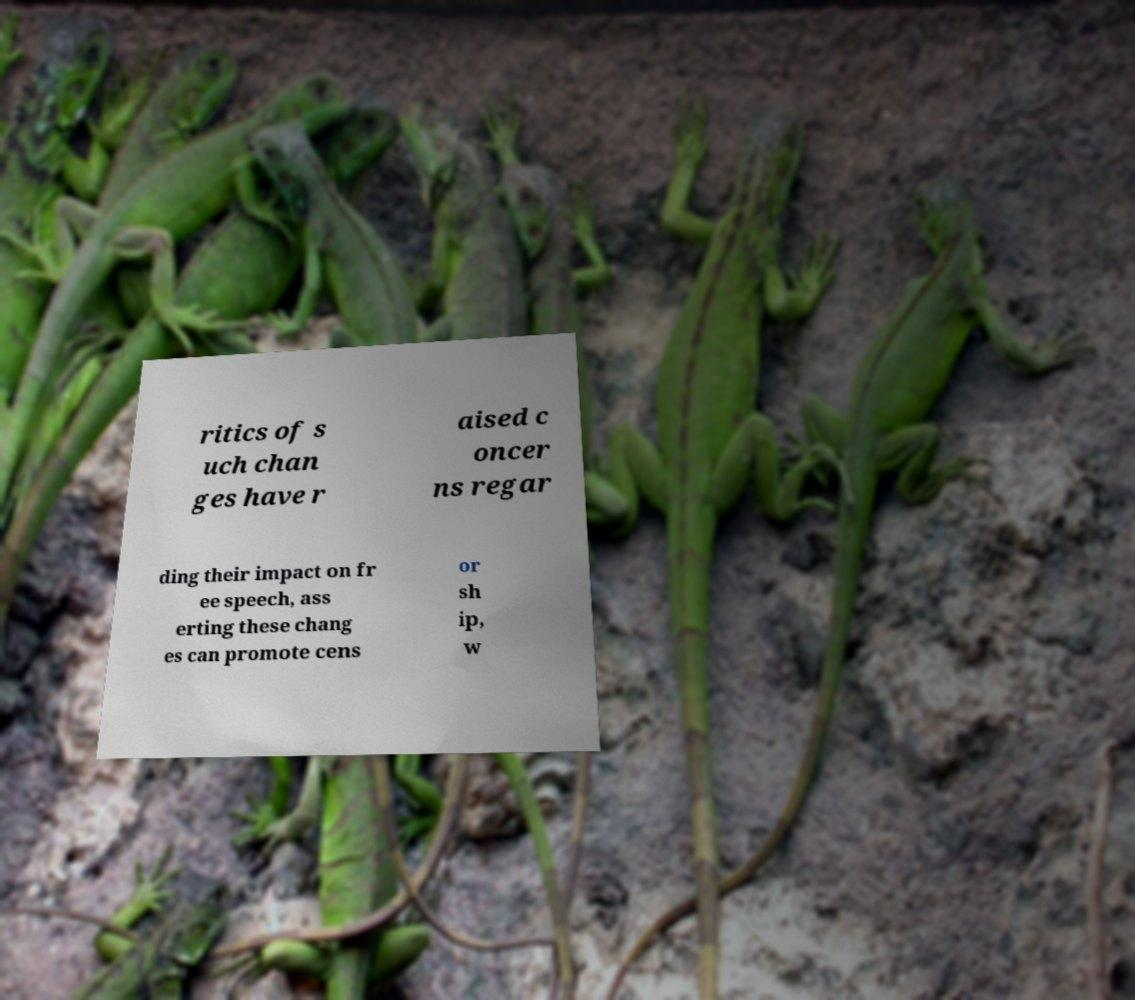There's text embedded in this image that I need extracted. Can you transcribe it verbatim? ritics of s uch chan ges have r aised c oncer ns regar ding their impact on fr ee speech, ass erting these chang es can promote cens or sh ip, w 